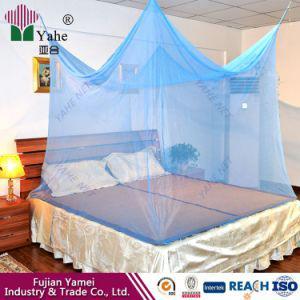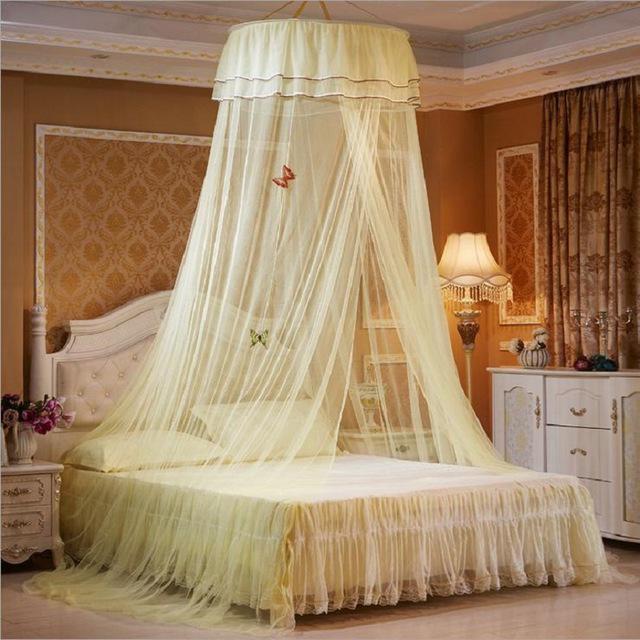The first image is the image on the left, the second image is the image on the right. Considering the images on both sides, is "There is a round canopy bed in the right image." valid? Answer yes or no. Yes. The first image is the image on the left, the second image is the image on the right. For the images displayed, is the sentence "One image shows a gauzy pale canopy that drapes a bed from a round shape suspended from the ceiling, and the other image shows a canopy suspended from four corners." factually correct? Answer yes or no. Yes. 